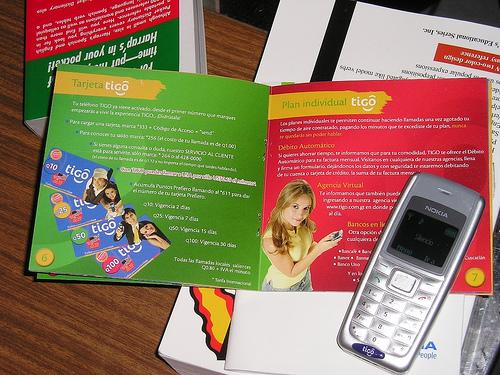What is the silver device on the red paper used for?

Choices:
A) paper weight
B) making calls
C) blending food
D) cracking nuts making calls 